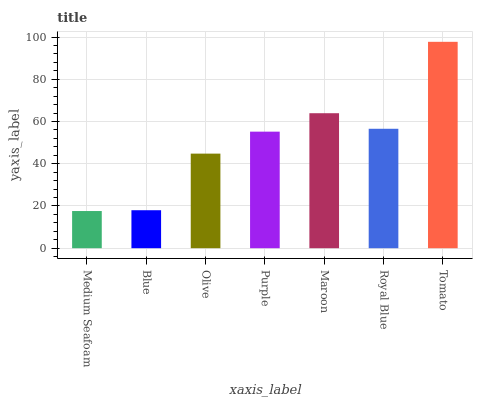Is Medium Seafoam the minimum?
Answer yes or no. Yes. Is Tomato the maximum?
Answer yes or no. Yes. Is Blue the minimum?
Answer yes or no. No. Is Blue the maximum?
Answer yes or no. No. Is Blue greater than Medium Seafoam?
Answer yes or no. Yes. Is Medium Seafoam less than Blue?
Answer yes or no. Yes. Is Medium Seafoam greater than Blue?
Answer yes or no. No. Is Blue less than Medium Seafoam?
Answer yes or no. No. Is Purple the high median?
Answer yes or no. Yes. Is Purple the low median?
Answer yes or no. Yes. Is Olive the high median?
Answer yes or no. No. Is Olive the low median?
Answer yes or no. No. 